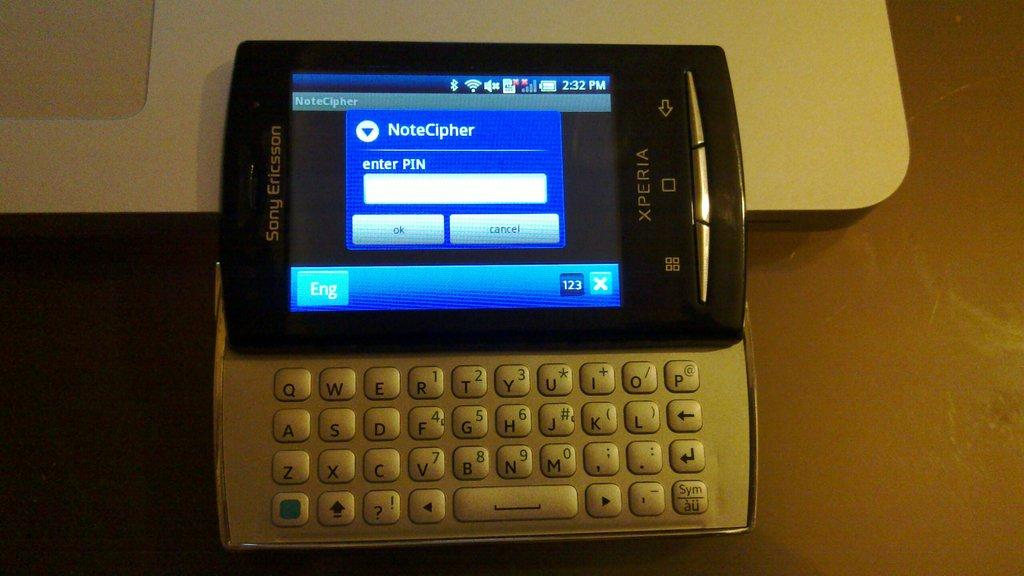<image>
Render a clear and concise summary of the photo. A flip phone with a program called NoteCipher open on it 